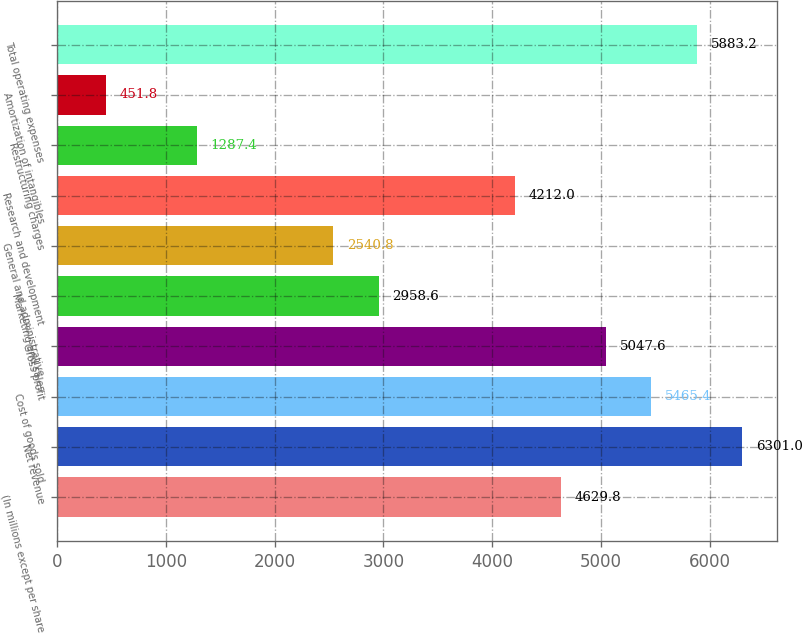Convert chart. <chart><loc_0><loc_0><loc_500><loc_500><bar_chart><fcel>(In millions except per share<fcel>Net revenue<fcel>Cost of goods sold<fcel>Gross profit<fcel>Marketing and sales<fcel>General and administrative<fcel>Research and development<fcel>Restructuring charges<fcel>Amortization of intangibles<fcel>Total operating expenses<nl><fcel>4629.8<fcel>6301<fcel>5465.4<fcel>5047.6<fcel>2958.6<fcel>2540.8<fcel>4212<fcel>1287.4<fcel>451.8<fcel>5883.2<nl></chart> 